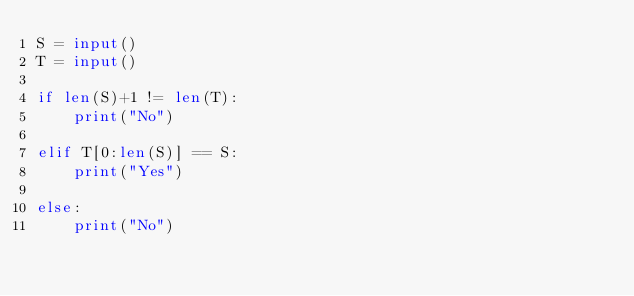<code> <loc_0><loc_0><loc_500><loc_500><_Python_>S = input()
T = input()

if len(S)+1 != len(T):
    print("No")

elif T[0:len(S)] == S:
    print("Yes")

else:
    print("No")</code> 